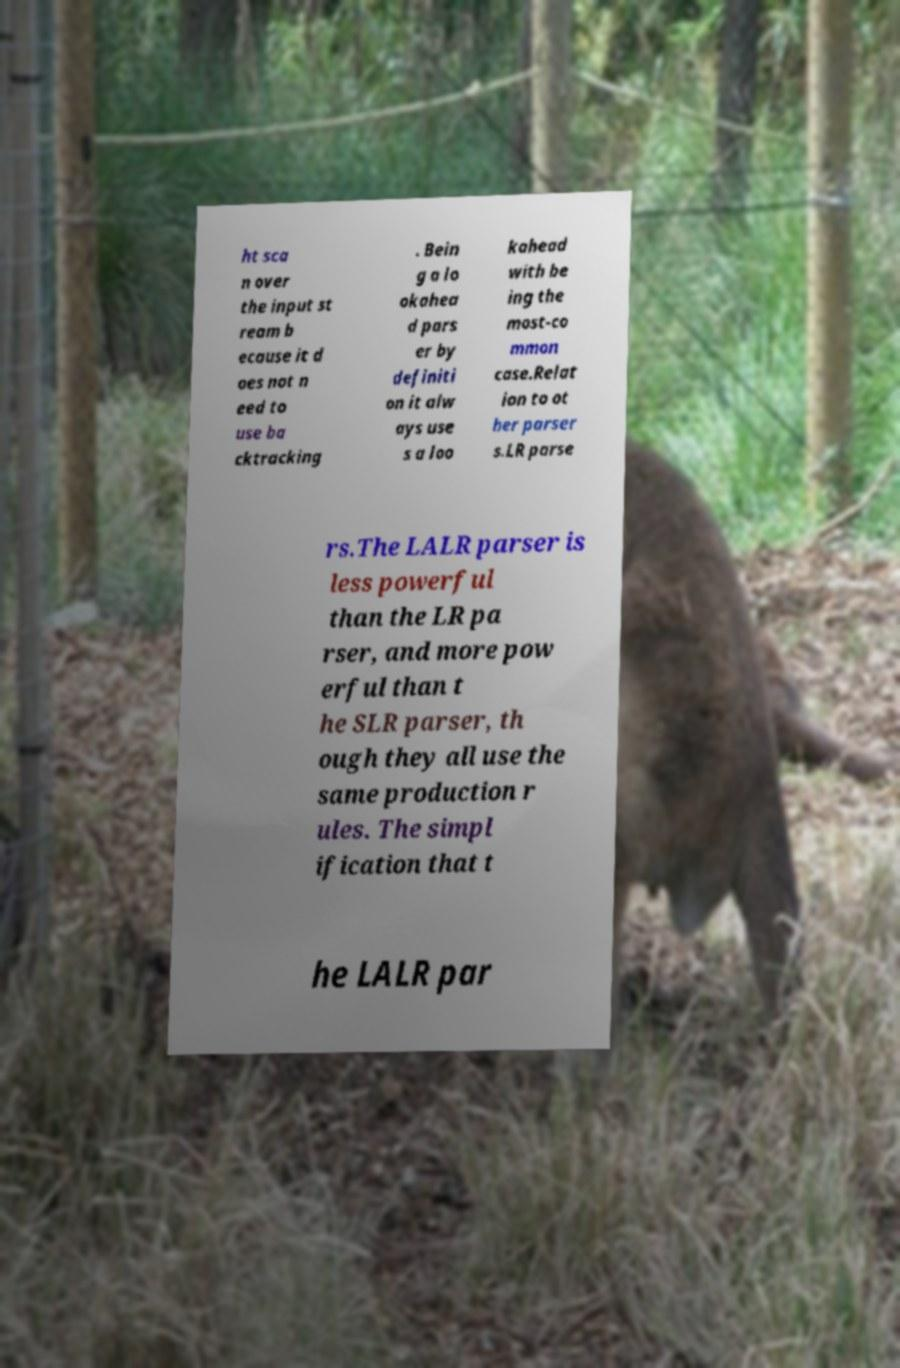Can you read and provide the text displayed in the image?This photo seems to have some interesting text. Can you extract and type it out for me? ht sca n over the input st ream b ecause it d oes not n eed to use ba cktracking . Bein g a lo okahea d pars er by definiti on it alw ays use s a loo kahead with be ing the most-co mmon case.Relat ion to ot her parser s.LR parse rs.The LALR parser is less powerful than the LR pa rser, and more pow erful than t he SLR parser, th ough they all use the same production r ules. The simpl ification that t he LALR par 